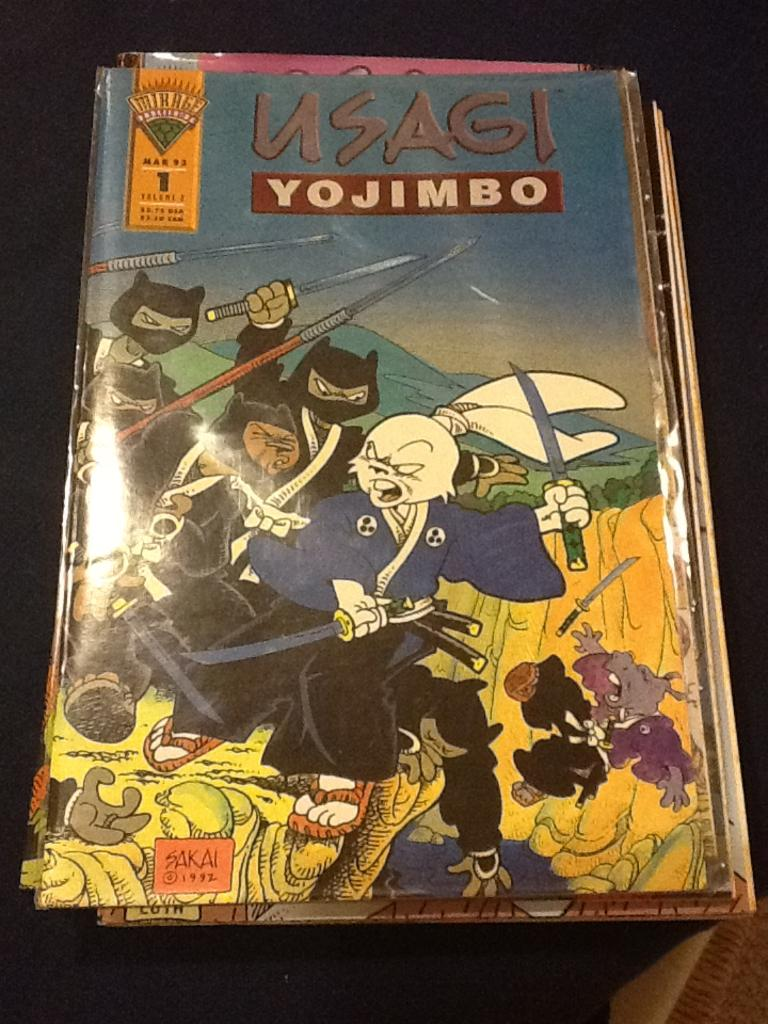<image>
Give a short and clear explanation of the subsequent image. An old animated comic book titled Usagi Yojimbo. 